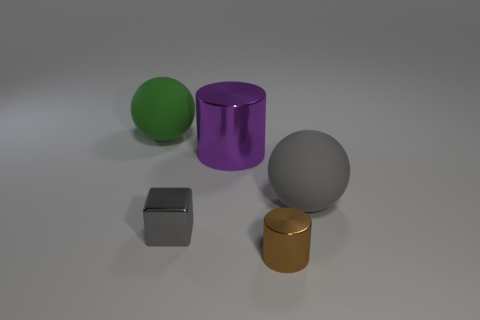Add 4 rubber things. How many objects exist? 9 Subtract all cylinders. How many objects are left? 3 Subtract all spheres. Subtract all shiny blocks. How many objects are left? 2 Add 4 brown shiny cylinders. How many brown shiny cylinders are left? 5 Add 1 big matte things. How many big matte things exist? 3 Subtract 0 purple cubes. How many objects are left? 5 